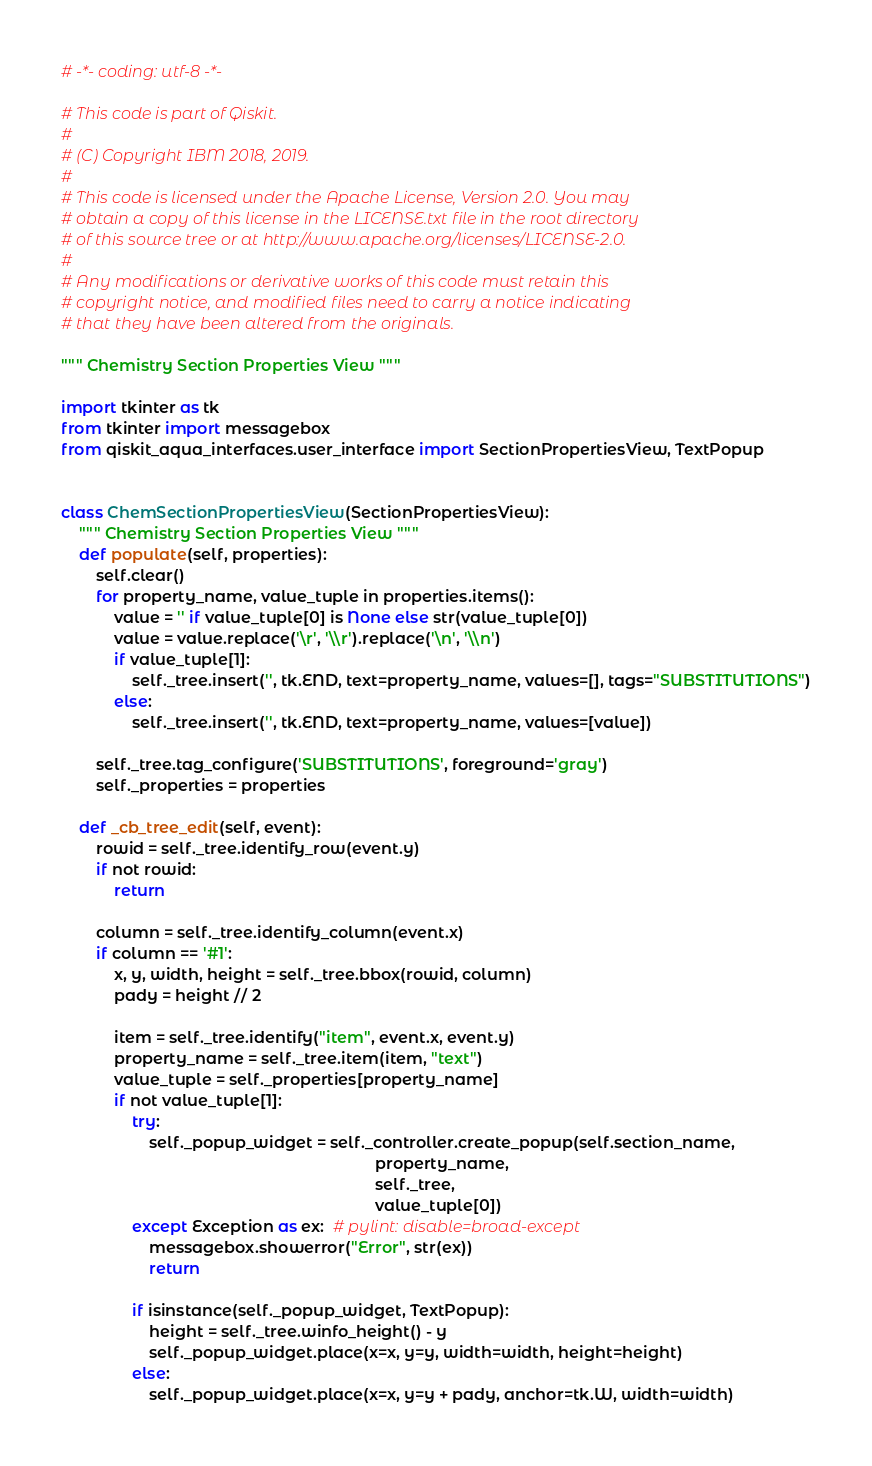Convert code to text. <code><loc_0><loc_0><loc_500><loc_500><_Python_># -*- coding: utf-8 -*-

# This code is part of Qiskit.
#
# (C) Copyright IBM 2018, 2019.
#
# This code is licensed under the Apache License, Version 2.0. You may
# obtain a copy of this license in the LICENSE.txt file in the root directory
# of this source tree or at http://www.apache.org/licenses/LICENSE-2.0.
#
# Any modifications or derivative works of this code must retain this
# copyright notice, and modified files need to carry a notice indicating
# that they have been altered from the originals.

""" Chemistry Section Properties View """

import tkinter as tk
from tkinter import messagebox
from qiskit_aqua_interfaces.user_interface import SectionPropertiesView, TextPopup


class ChemSectionPropertiesView(SectionPropertiesView):
    """ Chemistry Section Properties View """
    def populate(self, properties):
        self.clear()
        for property_name, value_tuple in properties.items():
            value = '' if value_tuple[0] is None else str(value_tuple[0])
            value = value.replace('\r', '\\r').replace('\n', '\\n')
            if value_tuple[1]:
                self._tree.insert('', tk.END, text=property_name, values=[], tags="SUBSTITUTIONS")
            else:
                self._tree.insert('', tk.END, text=property_name, values=[value])

        self._tree.tag_configure('SUBSTITUTIONS', foreground='gray')
        self._properties = properties

    def _cb_tree_edit(self, event):
        rowid = self._tree.identify_row(event.y)
        if not rowid:
            return

        column = self._tree.identify_column(event.x)
        if column == '#1':
            x, y, width, height = self._tree.bbox(rowid, column)
            pady = height // 2

            item = self._tree.identify("item", event.x, event.y)
            property_name = self._tree.item(item, "text")
            value_tuple = self._properties[property_name]
            if not value_tuple[1]:
                try:
                    self._popup_widget = self._controller.create_popup(self.section_name,
                                                                       property_name,
                                                                       self._tree,
                                                                       value_tuple[0])
                except Exception as ex:  # pylint: disable=broad-except
                    messagebox.showerror("Error", str(ex))
                    return

                if isinstance(self._popup_widget, TextPopup):
                    height = self._tree.winfo_height() - y
                    self._popup_widget.place(x=x, y=y, width=width, height=height)
                else:
                    self._popup_widget.place(x=x, y=y + pady, anchor=tk.W, width=width)
</code> 